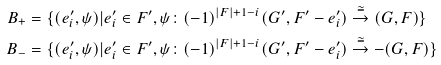<formula> <loc_0><loc_0><loc_500><loc_500>B _ { + } & = \{ ( e _ { i } ^ { \prime } , \psi ) | e _ { i } ^ { \prime } \in F ^ { \prime } , \psi \colon ( - 1 ) ^ { | F | + 1 - i } ( G ^ { \prime } , F ^ { \prime } - e _ { i } ^ { \prime } ) \overset { \cong } { \to } ( G , F ) \} \\ B _ { - } & = \{ ( e _ { i } ^ { \prime } , \psi ) | e _ { i } ^ { \prime } \in F ^ { \prime } , \psi \colon ( - 1 ) ^ { | F | + 1 - i } ( G ^ { \prime } , F ^ { \prime } - e _ { i } ^ { \prime } ) \overset { \cong } { \to } - ( G , F ) \}</formula> 